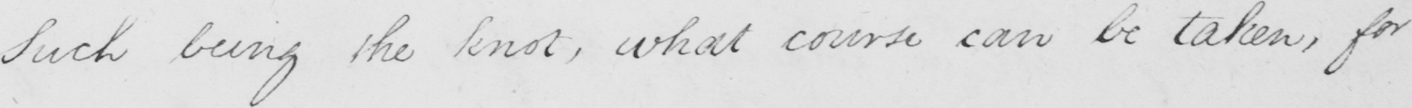Transcribe the text shown in this historical manuscript line. Such being the knot , what course can be taken , for 